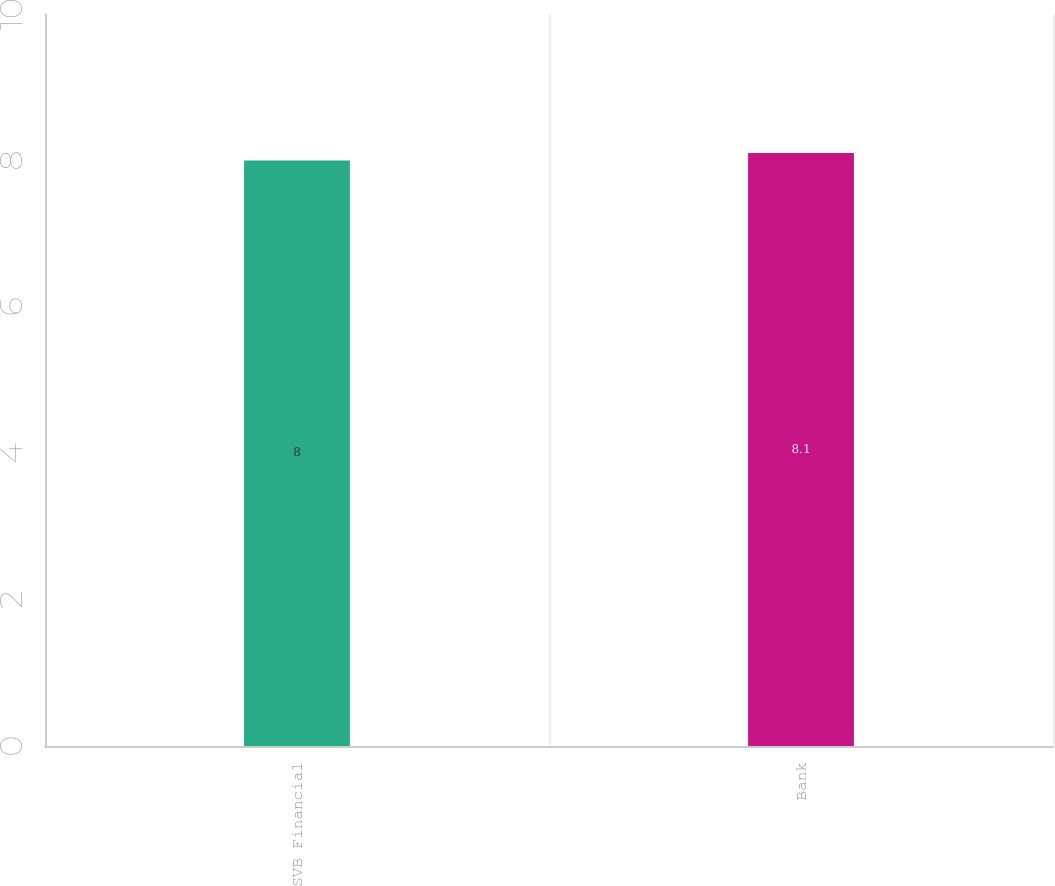<chart> <loc_0><loc_0><loc_500><loc_500><bar_chart><fcel>SVB Financial<fcel>Bank<nl><fcel>8<fcel>8.1<nl></chart> 